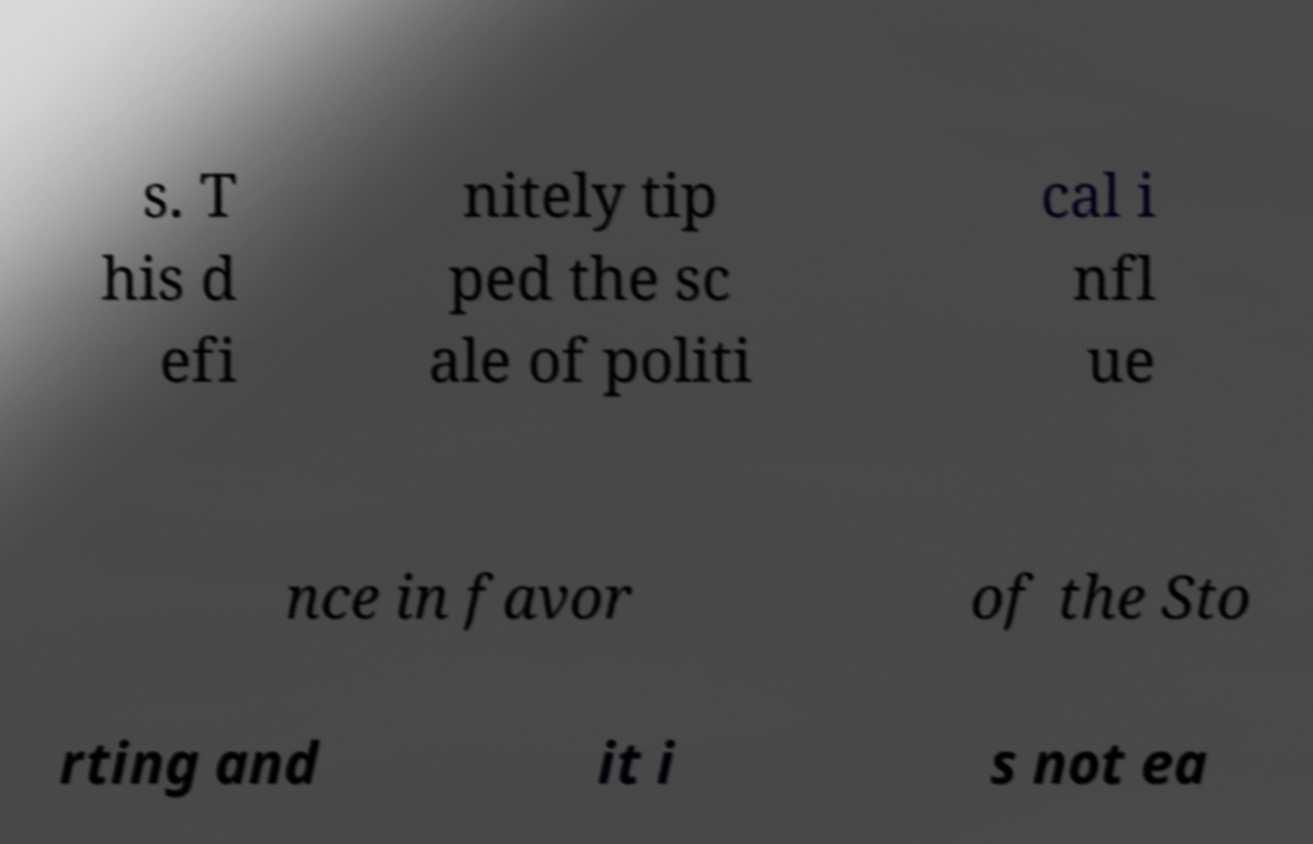Can you accurately transcribe the text from the provided image for me? s. T his d efi nitely tip ped the sc ale of politi cal i nfl ue nce in favor of the Sto rting and it i s not ea 